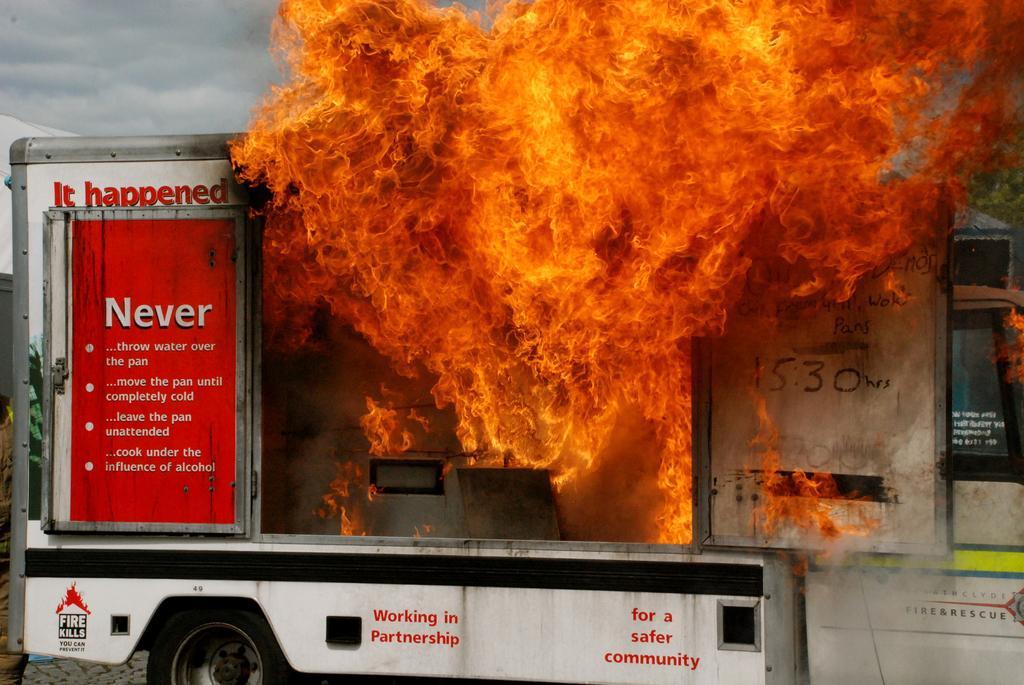Please provide a concise description of this image. In the image we can see there is a vehicle which has caught fire. 